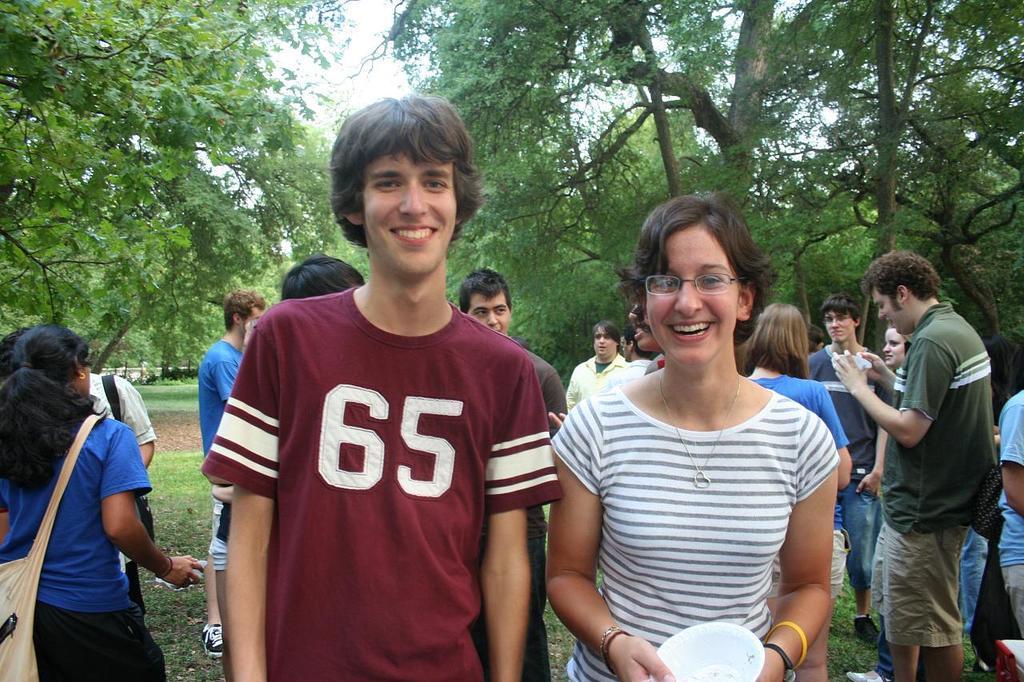Could you give a brief overview of what you see in this image? In this image we can see a group of people standing on the ground, among them, some are holding the objects, there are some trees, grass and the wall, in the background, we can see the sky. 